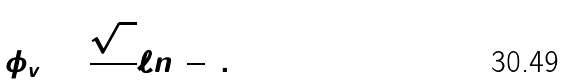Convert formula to latex. <formula><loc_0><loc_0><loc_500><loc_500>\phi _ { v } = \frac { \sqrt { 3 } } { 2 } \ell n ( { \frac { 3 } { 2 } } ) .</formula> 